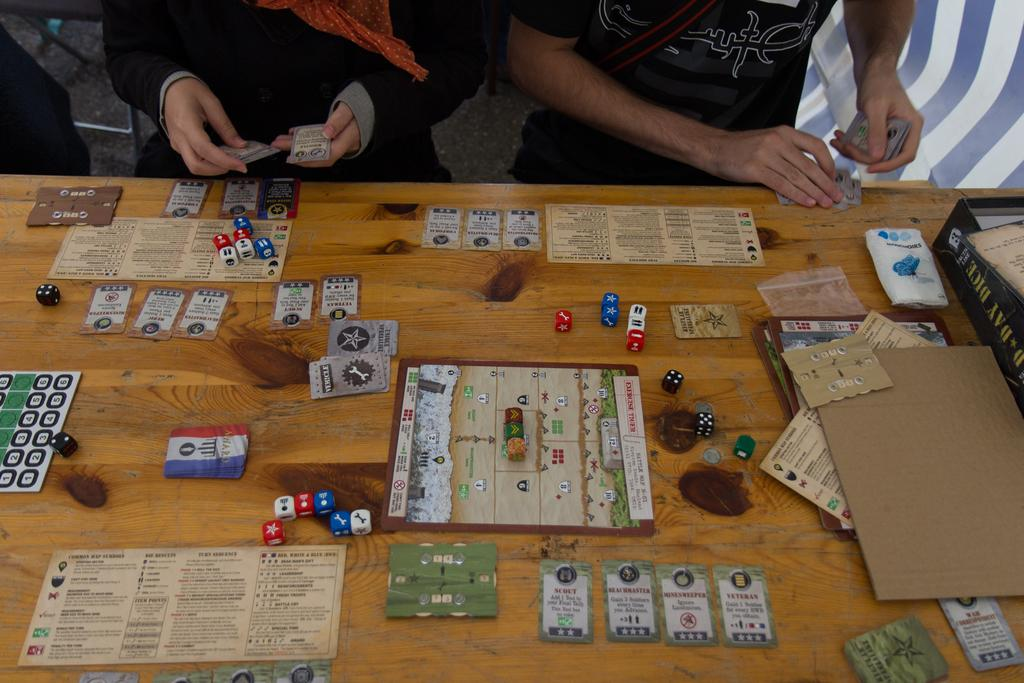What is the main object in the image? There is a table in the image. What items can be seen on the table? There are dice, cards, a cardboard, and paper on the table. What are the two persons holding in front of the table? The two persons are holding cards in front of the table. What else is present in the image? There is a box in the image. What month is it in the image? The image does not provide any information about the month or time of year. Can you see a field in the image? There is no field present in the image. 